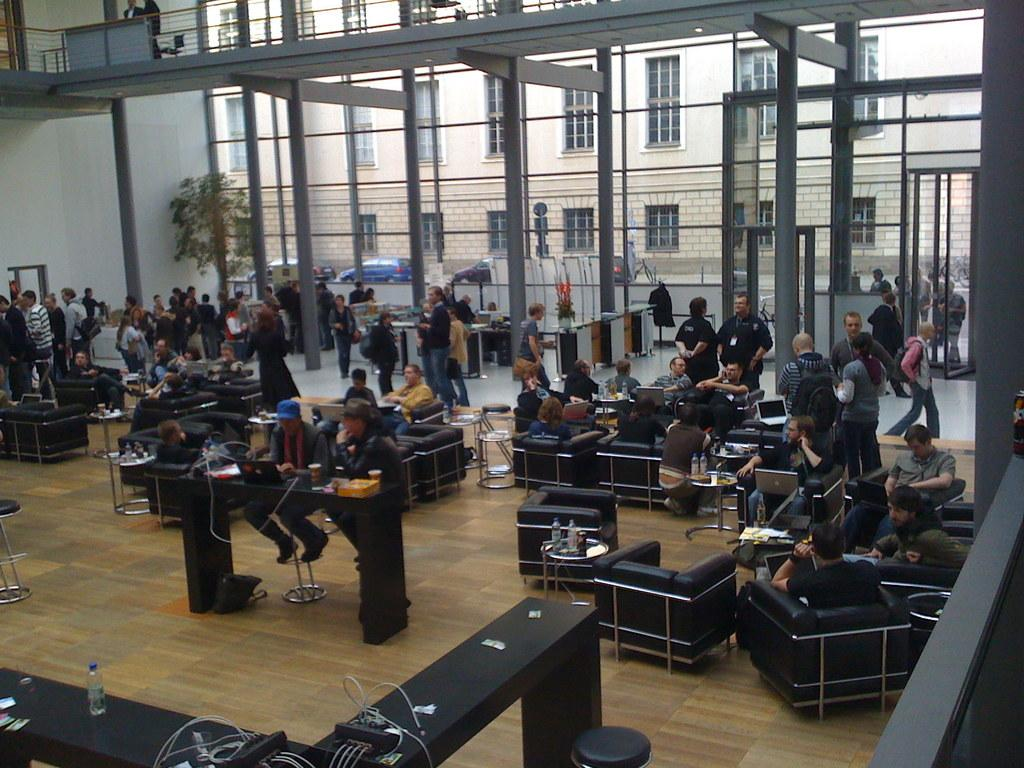Where was the image taken? The image was taken in a building. What type of furniture can be seen in the building? There are tables, chairs, and benches in the building. Are there any people present in the image? Yes, there are people in the building. What can be seen in the background of the image? There is a building with windows in the background. What type of flesh can be seen on the kitty's nose in the image? There is no kitty or nose present in the image; it features people and furniture in a building. 